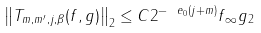Convert formula to latex. <formula><loc_0><loc_0><loc_500><loc_500>\left \| T _ { m , m ^ { \prime } , j , \beta } ( f , g ) \right \| _ { 2 } \leq C 2 ^ { - \ e _ { 0 } { ( j + m ) } } \| f \| _ { \infty } \| g \| _ { 2 } \,</formula> 